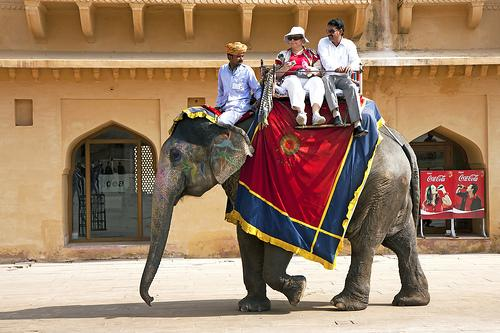Describe the clothing or accessories worn by one of the people on the elephant. The elephant driver is wearing a gold turban on his head and bright white pants, while also sporting sunglasses. Describe the appearance of the elephant in the image. The elephant has a colorful face and ears, a long trunk hanging towards the ground, and is wearing a covering of red, blue, and yellow fabric with gold details. Mention the activity of the people in the image. Three tourists are riding on an elephant, with one of them being the elephant driver, talking to the passengers during their tour. Describe the purpose of the ride the people are taking on the elephant. The people are on an elephant ride for tourists, with the driver giving them a guided tour and engaging them in conversation. Provide a brief overview of the scene in the image. Three people enjoy an elephant ride while the elephant walks on a smooth paved road wearing colorful fabric and paint, with a Coca-Cola advertisement visible in the background. What is noticeable about the background of the image? There is a building with an arched doorway and a window, a Coca-Cola advertisement on its facade, and a large shadow can be seen on the ground. Mention a detail about the elephant's trunk and tusks. The elephant's trunk is painted and hangs down towards the ground, and one of its tusks is close to the ground as well. Give a description of the elephant's back in the image. The elephant's back is covered with a large red and blue scarf, a yellow and gold cloth, and a seat for the passengers to sit on. Explain the context in which the people are riding the elephant. The three people, including an elephant driver, are enjoying a tour on the elephant, who is walking on a street by a building with Coca-Cola advertisements. Briefly describe the interaction between the elephant driver and the passengers. The elephant driver is talking to his passengers while guiding the elephant, ensuring they enjoy and learn during the tour. 